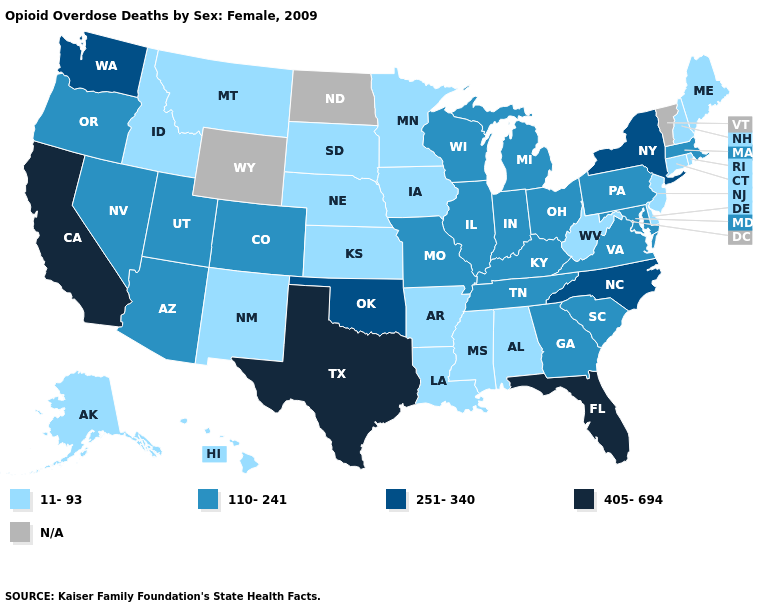What is the highest value in the USA?
Quick response, please. 405-694. Name the states that have a value in the range 11-93?
Short answer required. Alabama, Alaska, Arkansas, Connecticut, Delaware, Hawaii, Idaho, Iowa, Kansas, Louisiana, Maine, Minnesota, Mississippi, Montana, Nebraska, New Hampshire, New Jersey, New Mexico, Rhode Island, South Dakota, West Virginia. What is the lowest value in the USA?
Answer briefly. 11-93. Name the states that have a value in the range 251-340?
Answer briefly. New York, North Carolina, Oklahoma, Washington. Among the states that border New York , which have the highest value?
Concise answer only. Massachusetts, Pennsylvania. What is the highest value in the MidWest ?
Keep it brief. 110-241. Name the states that have a value in the range 251-340?
Keep it brief. New York, North Carolina, Oklahoma, Washington. What is the value of Nebraska?
Give a very brief answer. 11-93. Which states hav the highest value in the Northeast?
Give a very brief answer. New York. What is the value of Nevada?
Be succinct. 110-241. Is the legend a continuous bar?
Be succinct. No. Does the map have missing data?
Be succinct. Yes. Does Maryland have the lowest value in the USA?
Answer briefly. No. Does Alabama have the lowest value in the USA?
Write a very short answer. Yes. Does the map have missing data?
Answer briefly. Yes. 